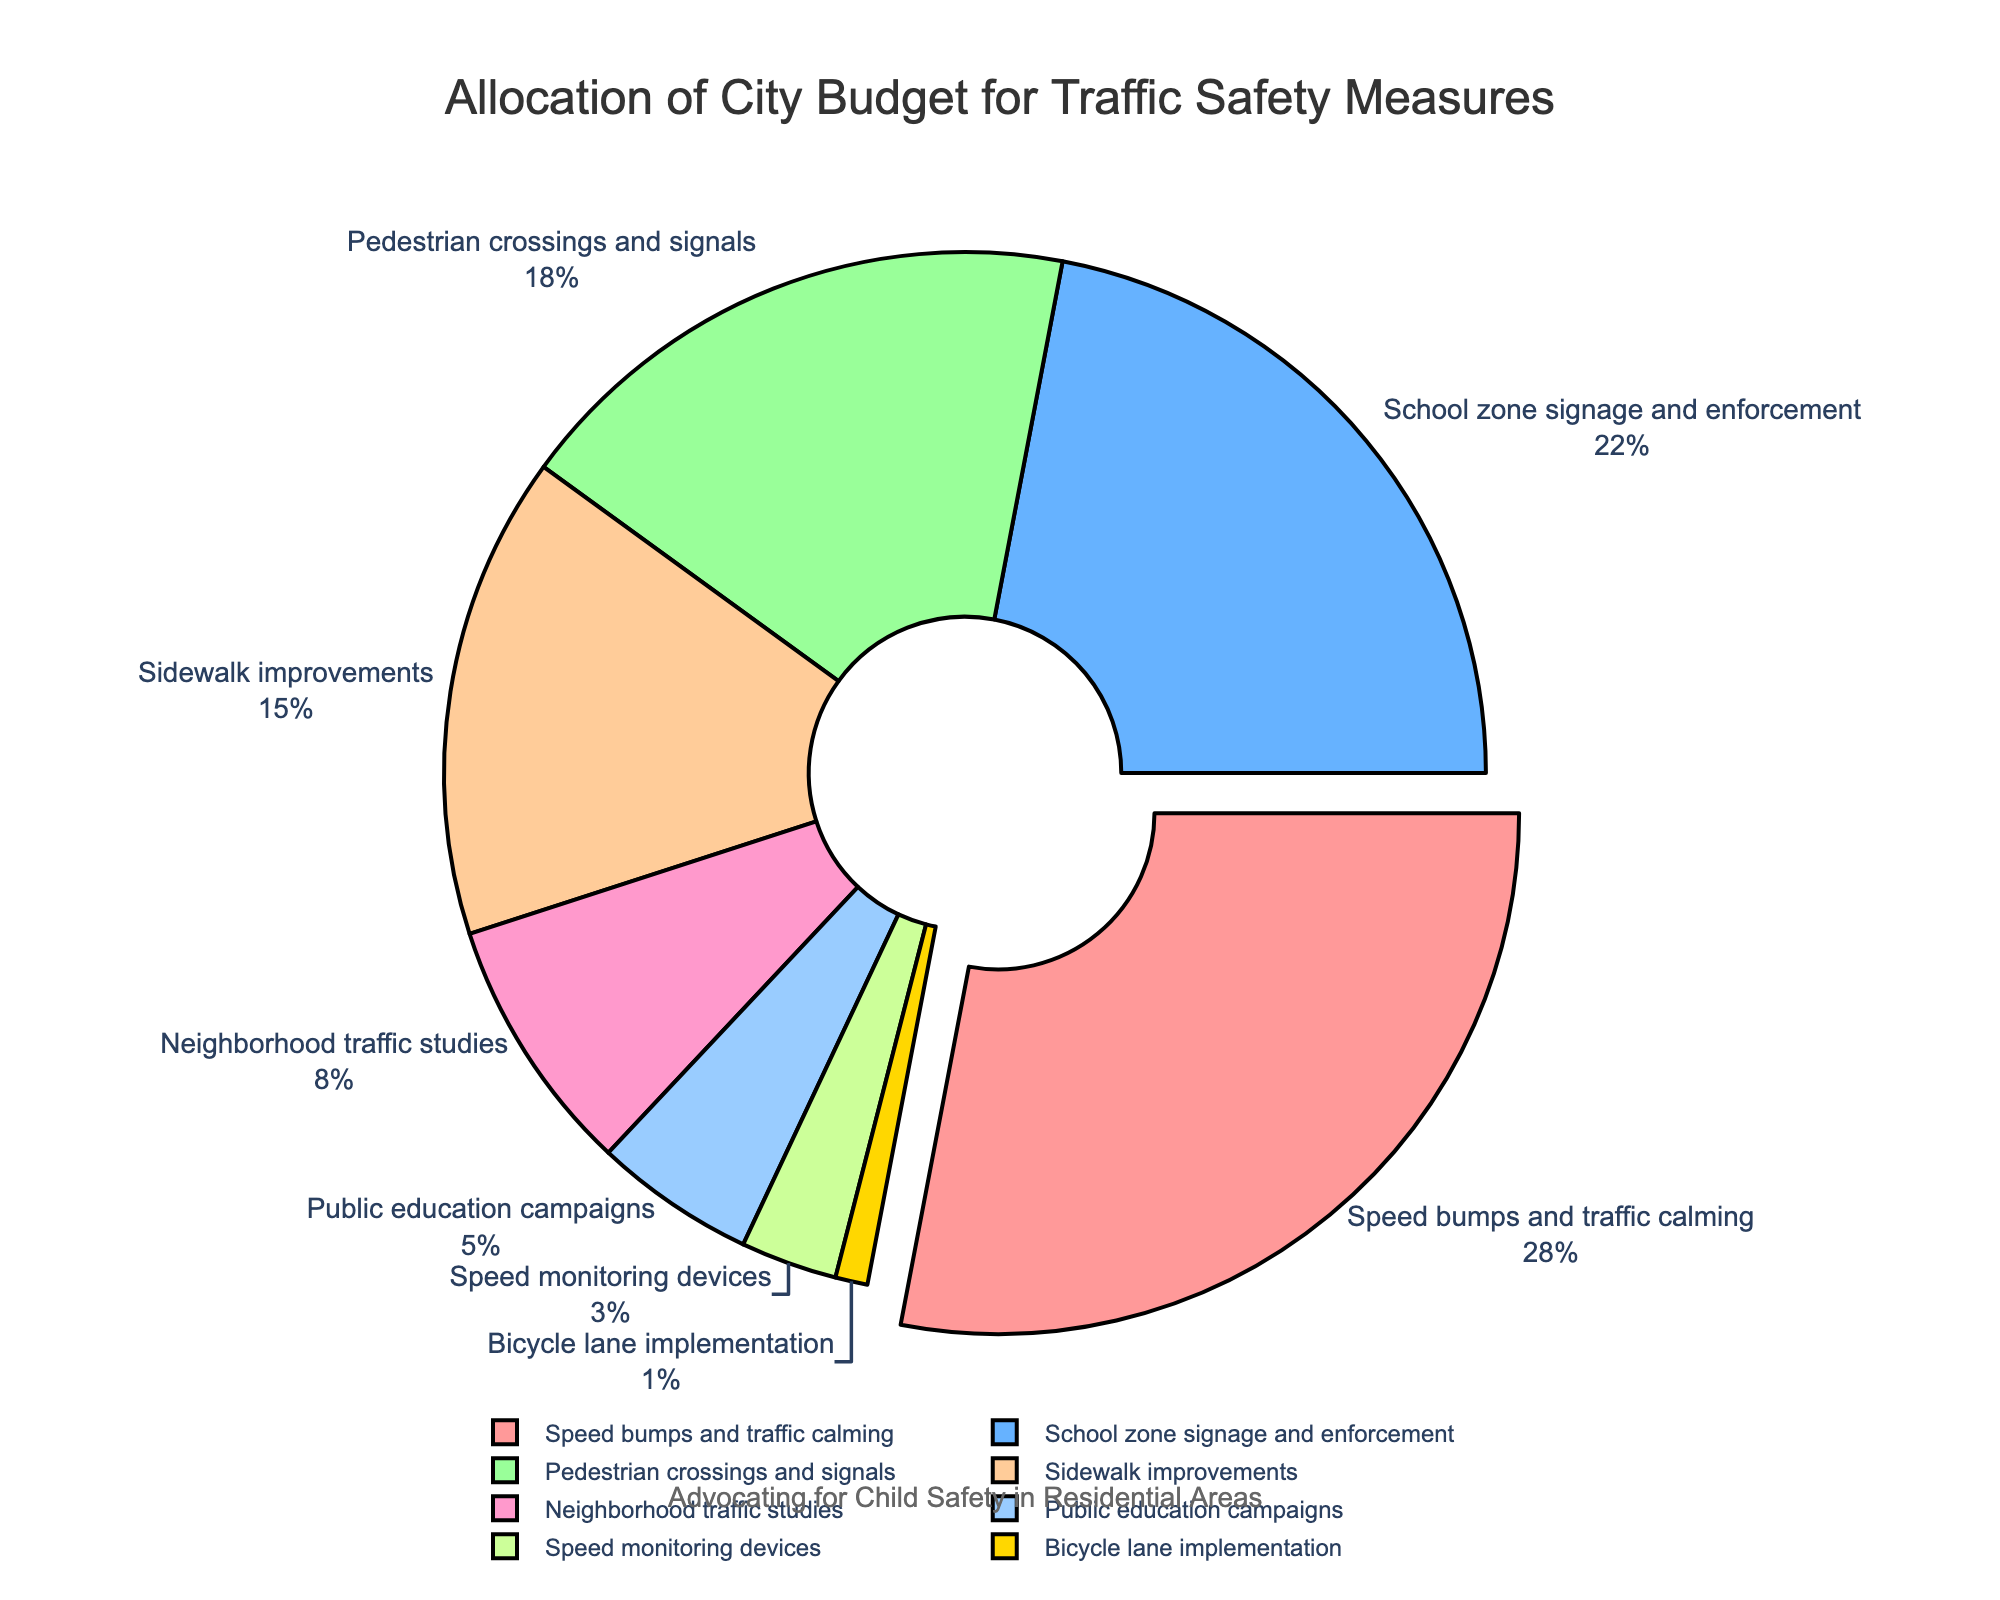What is the percentage allocated to 'Speed bumps and traffic calming'? The figure shows 'Speed bumps and traffic calming' as one of the categories with its percentage labeled around the pie slice.
Answer: 28% Which category receives the least funding? The smallest slice in the pie chart represents the category with the least funding. The category is 'Bicycle lane implementation'.
Answer: Bicycle lane implementation How much more budget percentage is allocated to 'School zone signage and enforcement' compared to 'Public education campaigns'? The percentage for 'School zone signage and enforcement' is 22%, and for 'Public education campaigns' is 5%. The difference between these percentages is calculated as 22% - 5%.
Answer: 17% In terms of percentage, are 'Speed monitoring devices' and 'Public education campaigns' jointly more than 'Speed bumps and traffic calming'? 'Speed monitoring devices' is 3% and 'Public education campaigns' is 5%, making their combined total 8%. 'Speed bumps and traffic calming' is 28%. 8% is not greater than 28%.
Answer: No Which categories collectively make up more than 50% of the budget? By adding the budgets of 'Speed bumps and traffic calming' (28%), 'School zone signage and enforcement' (22%), and 'Pedestrian crossings and signals' (18%), the sum is 68%, which is more than 50%.
Answer: Speed bumps and traffic calming, School zone signage and enforcement, Pedestrian crossings and signals What percentage of the budget is allocated to all types of signage and signals (School zone signage and enforcement and Pedestrian crossings and signals)? The sum of the percentages for 'School zone signage and enforcement' (22%) and 'Pedestrian crossings and signals' (18%) is calculated as 22% + 18%.
Answer: 40% Is the budget for 'Sidewalk improvements' more than twice the budget for 'Neighborhood traffic studies'? The percentage for 'Sidewalk improvements' is 15%, and for 'Neighborhood traffic studies' is 8%. Doubling the percentage for 'Neighborhood traffic studies' gives 16%, which is more than 15%.
Answer: No What percentage of the budget is assigned to 'Speed bumps and traffic calming' and 'Sidewalk improvements' together? The sum of the percentages for 'Speed bumps and traffic calming' (28%) and 'Sidewalk improvements' (15%) is calculated as 28% + 15%.
Answer: 43% Are 'Speed bumps and traffic calming' and 'School zone signage and enforcement' together more than half of the total budget? The budget for 'Speed bumps and traffic calming' is 28%, and for 'School zone signage and enforcement' is 22%. Adding these gives 28% + 22% = 50%. Since 50% is exactly half, they are not more than half.
Answer: No 